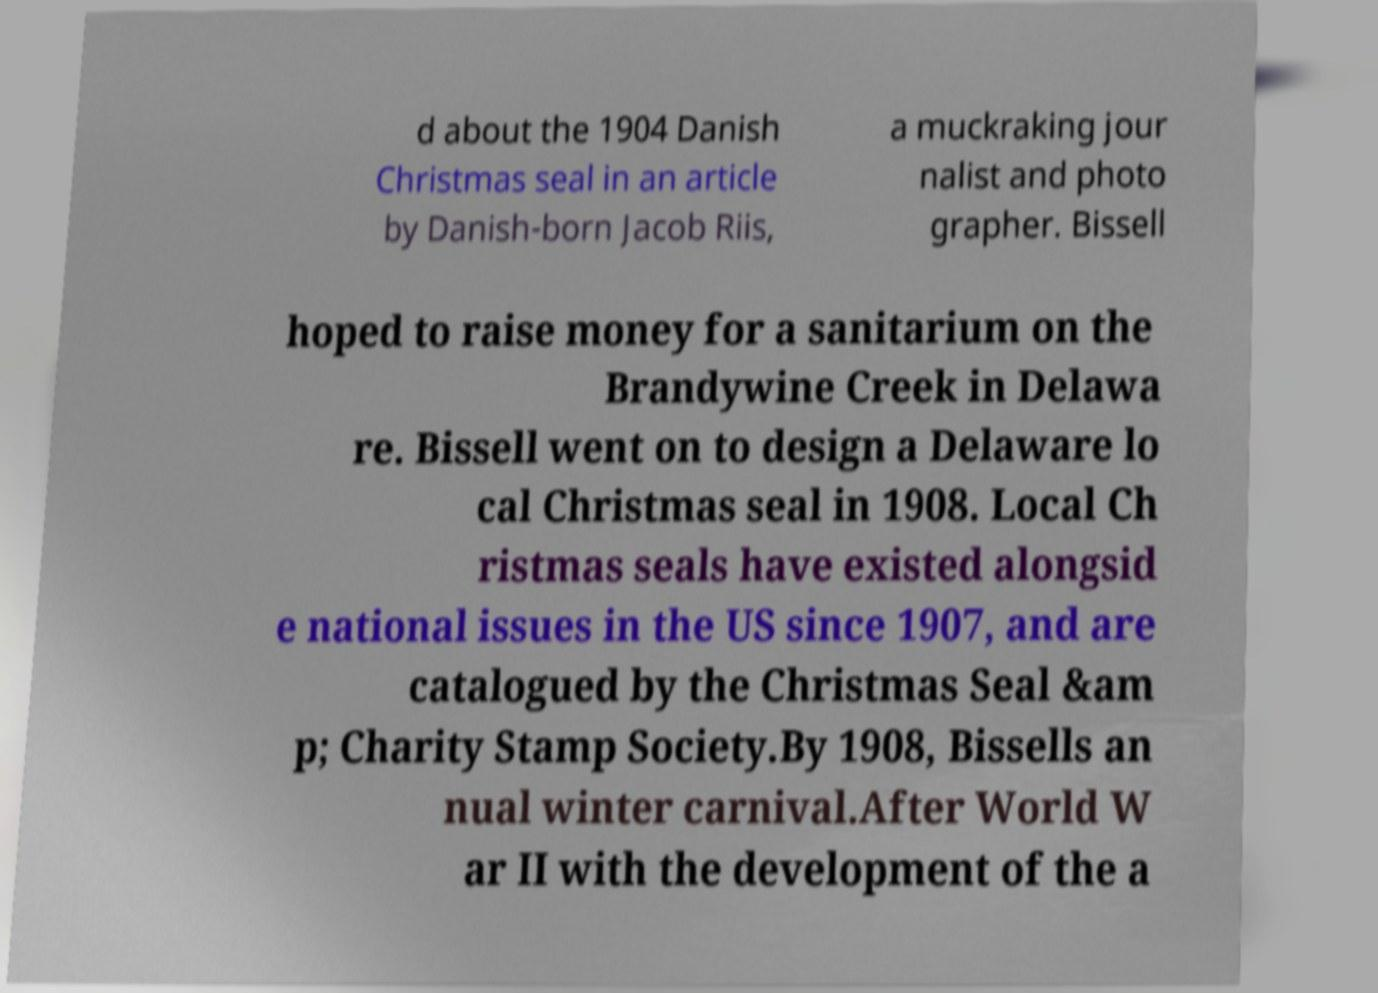Please identify and transcribe the text found in this image. d about the 1904 Danish Christmas seal in an article by Danish-born Jacob Riis, a muckraking jour nalist and photo grapher. Bissell hoped to raise money for a sanitarium on the Brandywine Creek in Delawa re. Bissell went on to design a Delaware lo cal Christmas seal in 1908. Local Ch ristmas seals have existed alongsid e national issues in the US since 1907, and are catalogued by the Christmas Seal &am p; Charity Stamp Society.By 1908, Bissells an nual winter carnival.After World W ar II with the development of the a 